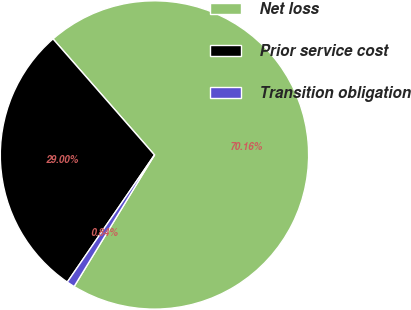Convert chart. <chart><loc_0><loc_0><loc_500><loc_500><pie_chart><fcel>Net loss<fcel>Prior service cost<fcel>Transition obligation<nl><fcel>70.16%<fcel>29.0%<fcel>0.84%<nl></chart> 